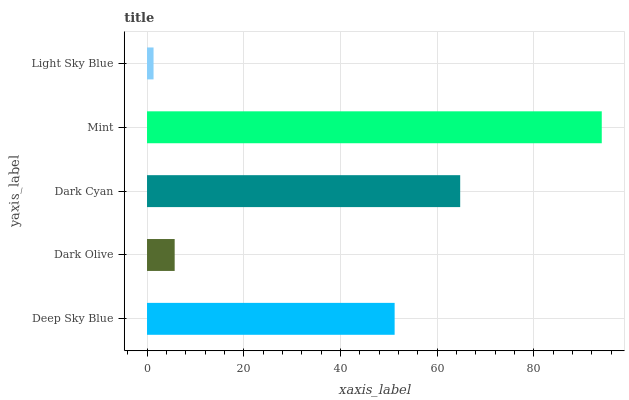Is Light Sky Blue the minimum?
Answer yes or no. Yes. Is Mint the maximum?
Answer yes or no. Yes. Is Dark Olive the minimum?
Answer yes or no. No. Is Dark Olive the maximum?
Answer yes or no. No. Is Deep Sky Blue greater than Dark Olive?
Answer yes or no. Yes. Is Dark Olive less than Deep Sky Blue?
Answer yes or no. Yes. Is Dark Olive greater than Deep Sky Blue?
Answer yes or no. No. Is Deep Sky Blue less than Dark Olive?
Answer yes or no. No. Is Deep Sky Blue the high median?
Answer yes or no. Yes. Is Deep Sky Blue the low median?
Answer yes or no. Yes. Is Dark Cyan the high median?
Answer yes or no. No. Is Dark Cyan the low median?
Answer yes or no. No. 